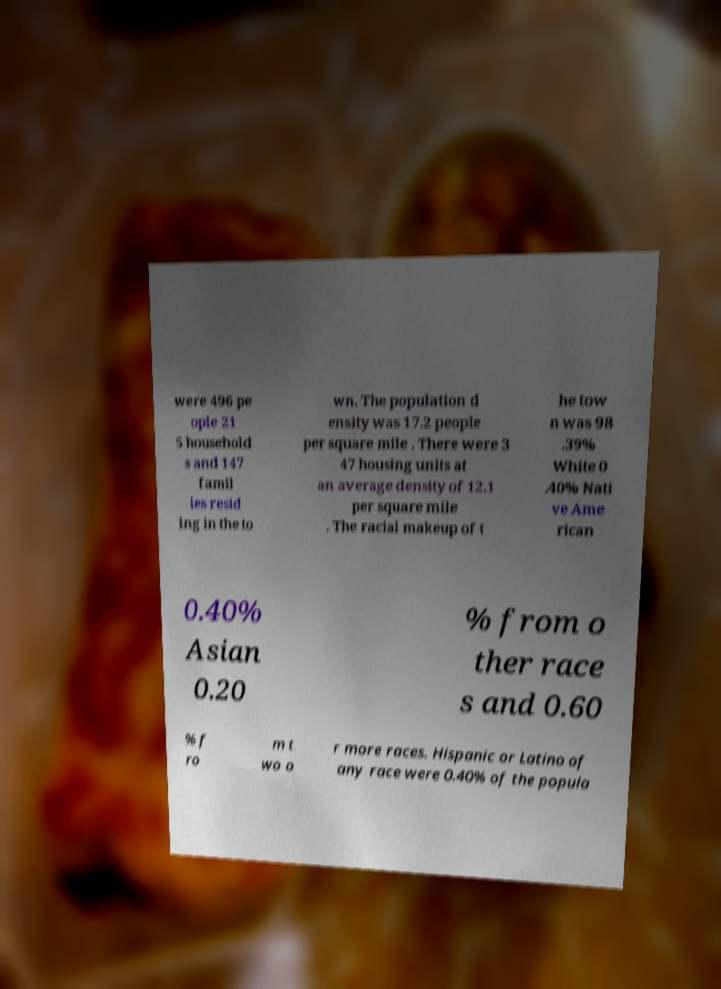I need the written content from this picture converted into text. Can you do that? were 496 pe ople 21 5 household s and 147 famil ies resid ing in the to wn. The population d ensity was 17.2 people per square mile . There were 3 47 housing units at an average density of 12.1 per square mile . The racial makeup of t he tow n was 98 .39% White 0 .40% Nati ve Ame rican 0.40% Asian 0.20 % from o ther race s and 0.60 % f ro m t wo o r more races. Hispanic or Latino of any race were 0.40% of the popula 